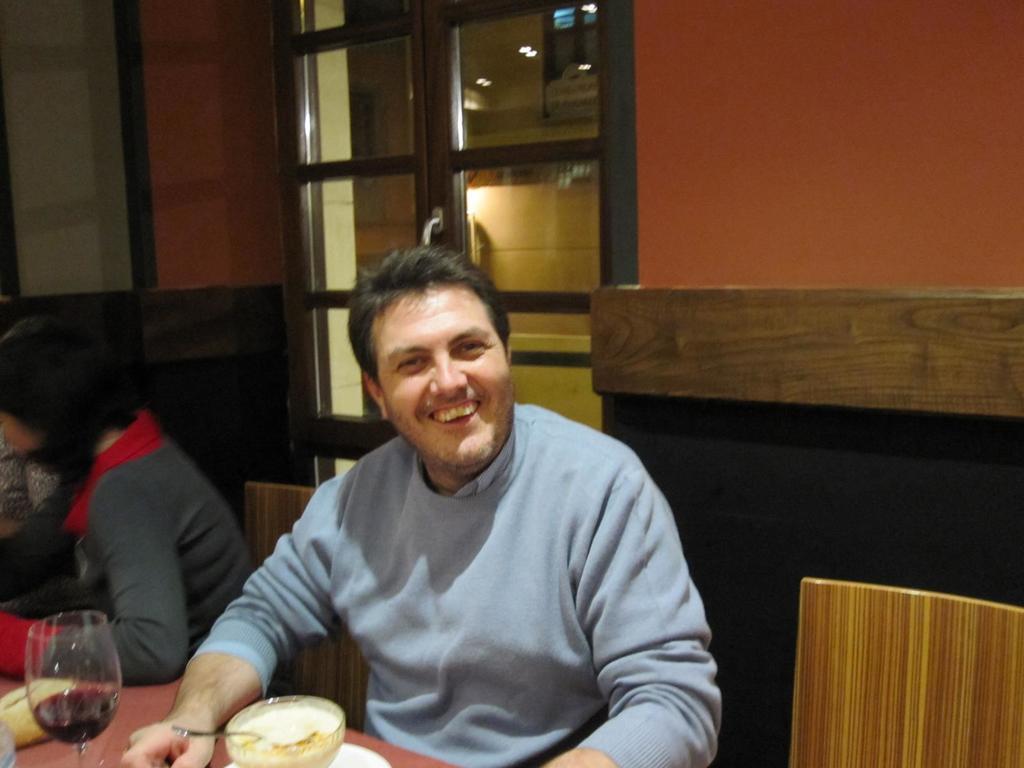Describe this image in one or two sentences. This is inside a room. In the middle a man is sitting in front of the dining table. He is wearing a blue sweater. he is smiling. His hands are on the dining table. On the table there is a wine glass ,a bowl with some food and a spoon on it, a plate. There are chairs. One lady is sitting beside the man. There is a glass window. 